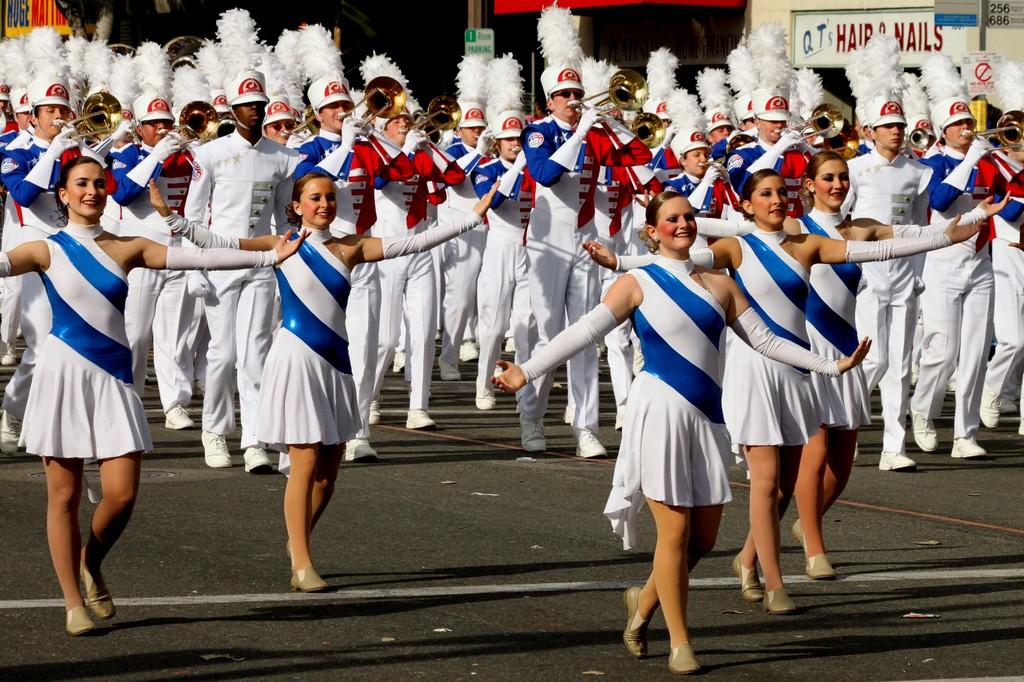What is the sign on the top right for?
Make the answer very short. Hair and nails. 